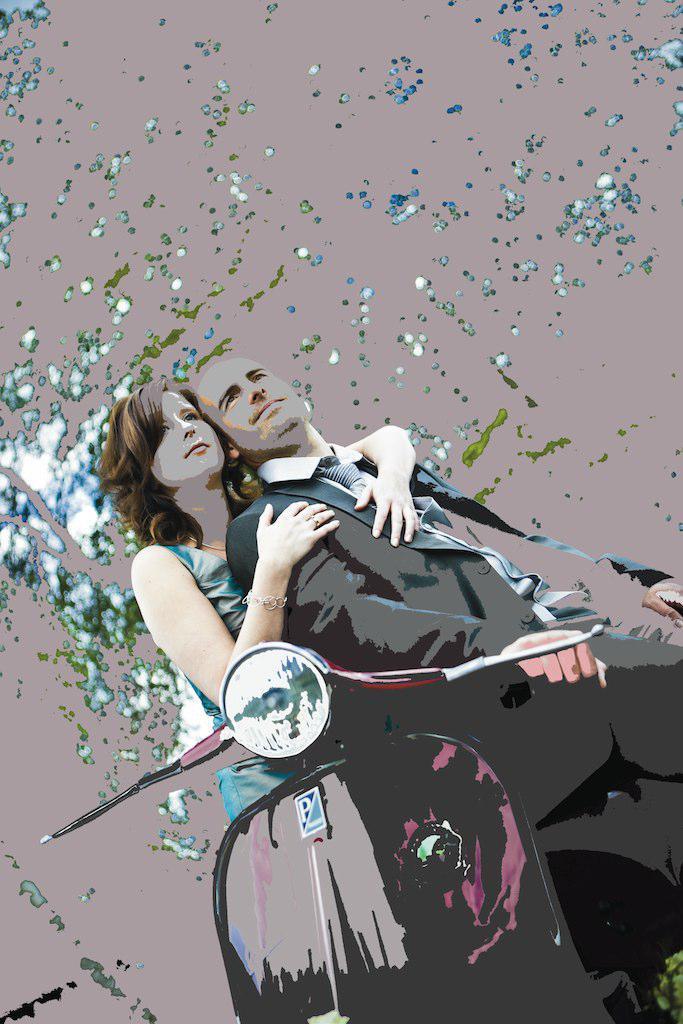Can you describe this image briefly? In this picture we can observe a painting of a couple. We can observe a man wearing a suit and sitting on the scooter. Behind him there is a woman. In the background we can observe some dots which are in blue and white color. 